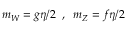<formula> <loc_0><loc_0><loc_500><loc_500>m _ { W } = g \eta / 2 \, , \, m _ { Z } = f \eta / 2</formula> 